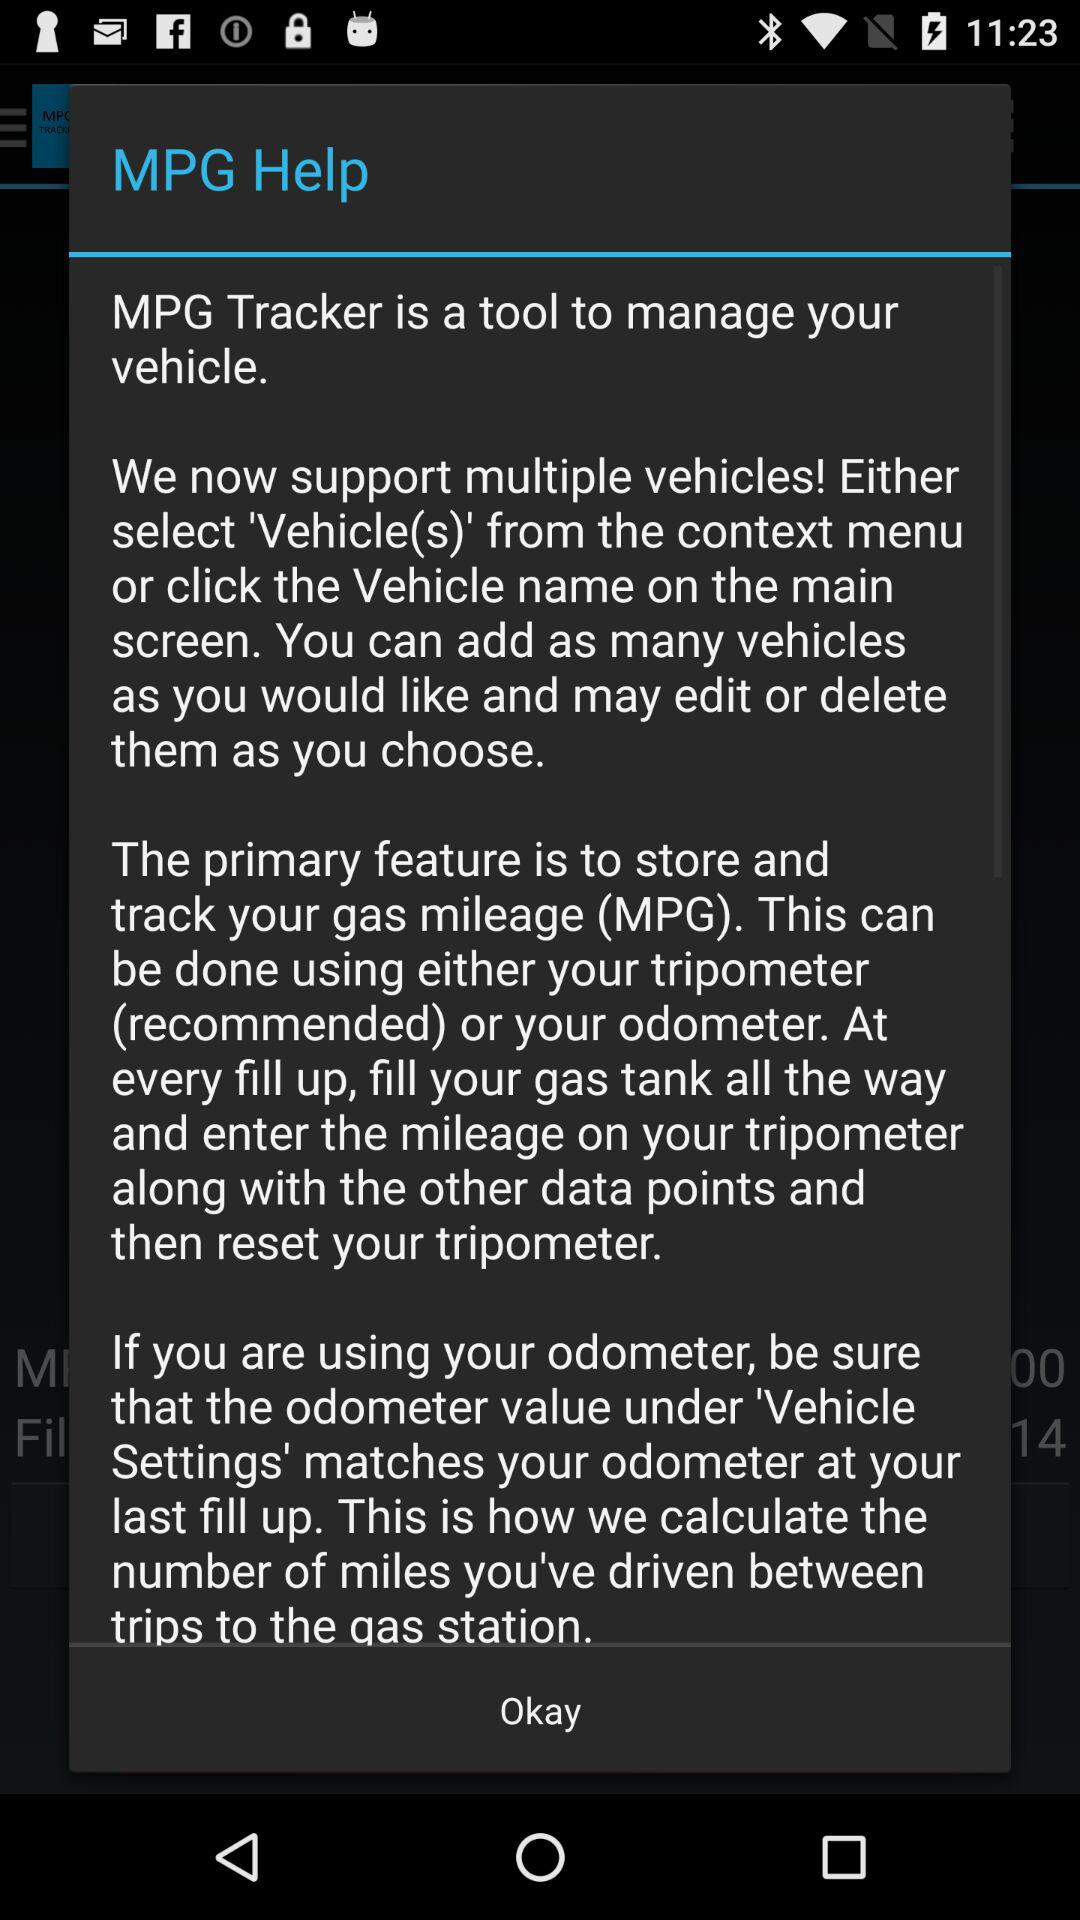What is the "MPG Tracker"? The "MPG Tracker" is a tool to manage your vehicle. 